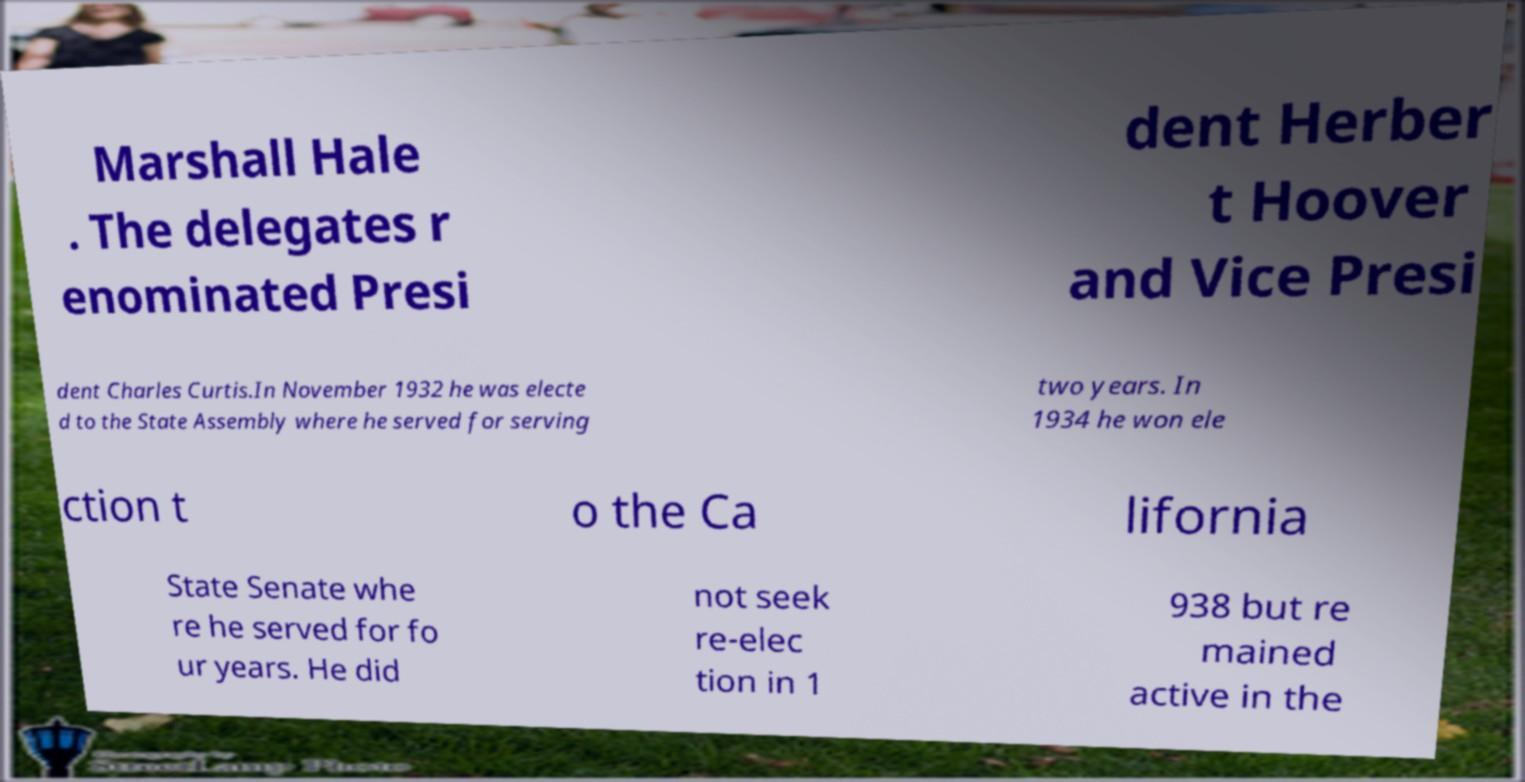What messages or text are displayed in this image? I need them in a readable, typed format. Marshall Hale . The delegates r enominated Presi dent Herber t Hoover and Vice Presi dent Charles Curtis.In November 1932 he was electe d to the State Assembly where he served for serving two years. In 1934 he won ele ction t o the Ca lifornia State Senate whe re he served for fo ur years. He did not seek re-elec tion in 1 938 but re mained active in the 